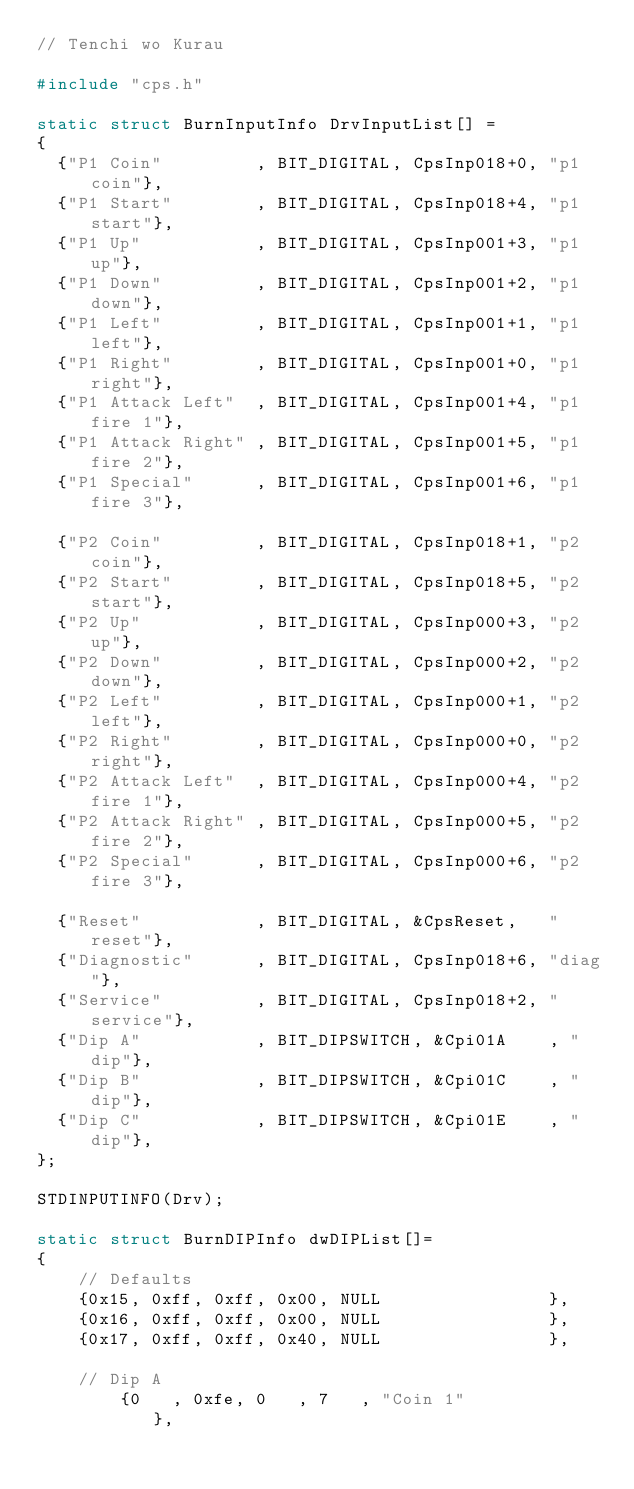<code> <loc_0><loc_0><loc_500><loc_500><_C++_>// Tenchi wo Kurau

#include "cps.h"

static struct BurnInputInfo DrvInputList[] =
{
  {"P1 Coin"         , BIT_DIGITAL, CpsInp018+0, "p1 coin"},
  {"P1 Start"        , BIT_DIGITAL, CpsInp018+4, "p1 start"},
  {"P1 Up"           , BIT_DIGITAL, CpsInp001+3, "p1 up"},
  {"P1 Down"         , BIT_DIGITAL, CpsInp001+2, "p1 down"},
  {"P1 Left"         , BIT_DIGITAL, CpsInp001+1, "p1 left"},
  {"P1 Right"        , BIT_DIGITAL, CpsInp001+0, "p1 right"},
  {"P1 Attack Left"  , BIT_DIGITAL, CpsInp001+4, "p1 fire 1"},
  {"P1 Attack Right" , BIT_DIGITAL, CpsInp001+5, "p1 fire 2"},
  {"P1 Special"      , BIT_DIGITAL, CpsInp001+6, "p1 fire 3"},

  {"P2 Coin"         , BIT_DIGITAL, CpsInp018+1, "p2 coin"},
  {"P2 Start"        , BIT_DIGITAL, CpsInp018+5, "p2 start"},
  {"P2 Up"           , BIT_DIGITAL, CpsInp000+3, "p2 up"},
  {"P2 Down"         , BIT_DIGITAL, CpsInp000+2, "p2 down"},
  {"P2 Left"         , BIT_DIGITAL, CpsInp000+1, "p2 left"},
  {"P2 Right"        , BIT_DIGITAL, CpsInp000+0, "p2 right"},
  {"P2 Attack Left"  , BIT_DIGITAL, CpsInp000+4, "p2 fire 1"},
  {"P2 Attack Right" , BIT_DIGITAL, CpsInp000+5, "p2 fire 2"},
  {"P2 Special"      , BIT_DIGITAL, CpsInp000+6, "p2 fire 3"},

  {"Reset"           , BIT_DIGITAL, &CpsReset,   "reset"},
  {"Diagnostic"      , BIT_DIGITAL, CpsInp018+6, "diag"},
  {"Service"         , BIT_DIGITAL, CpsInp018+2, "service"},
  {"Dip A"           , BIT_DIPSWITCH, &Cpi01A    , "dip"},
  {"Dip B"           , BIT_DIPSWITCH, &Cpi01C    , "dip"},
  {"Dip C"           , BIT_DIPSWITCH, &Cpi01E    , "dip"},
};

STDINPUTINFO(Drv);

static struct BurnDIPInfo dwDIPList[]=
{
	// Defaults
	{0x15, 0xff, 0xff, 0x00, NULL                },
	{0x16, 0xff, 0xff, 0x00, NULL                },
	{0x17, 0xff, 0xff, 0x40, NULL                },

	// Dip A
        {0   , 0xfe, 0   , 7   , "Coin 1"            },</code> 